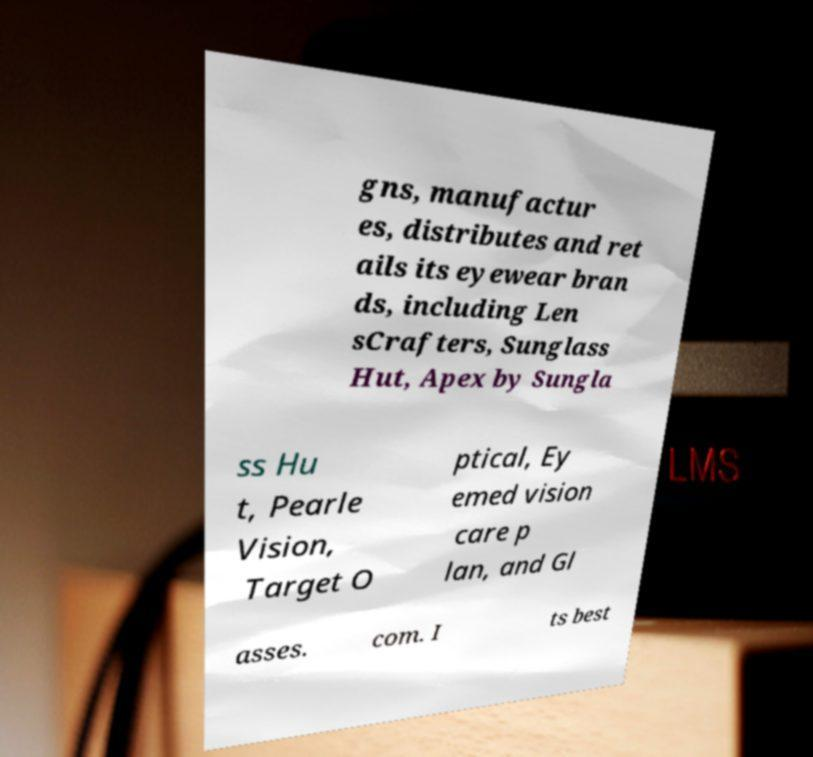What messages or text are displayed in this image? I need them in a readable, typed format. gns, manufactur es, distributes and ret ails its eyewear bran ds, including Len sCrafters, Sunglass Hut, Apex by Sungla ss Hu t, Pearle Vision, Target O ptical, Ey emed vision care p lan, and Gl asses. com. I ts best 